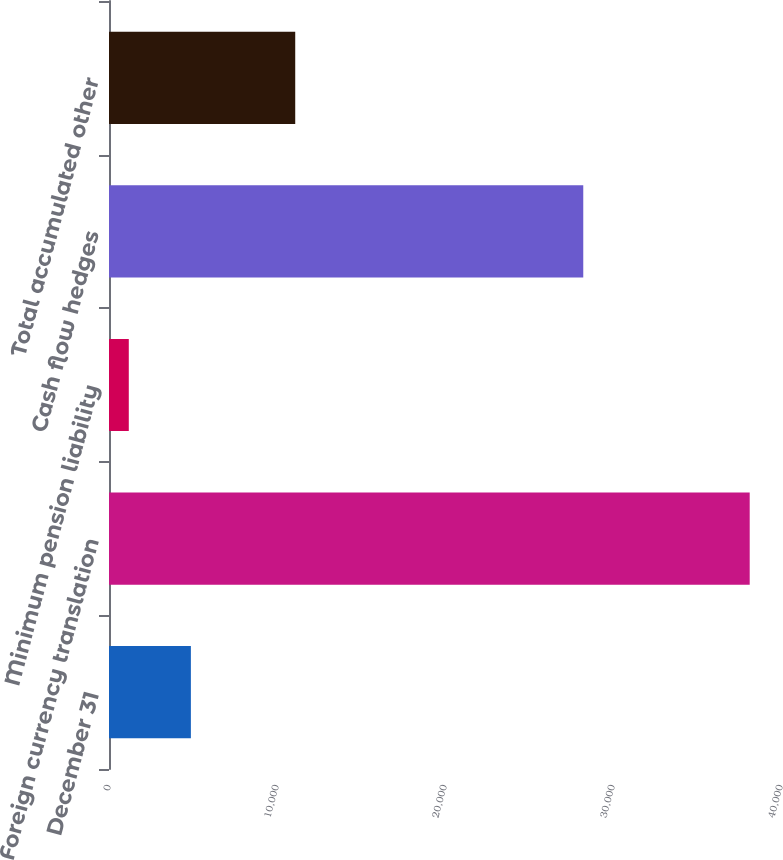Convert chart to OTSL. <chart><loc_0><loc_0><loc_500><loc_500><bar_chart><fcel>December 31<fcel>Foreign currency translation<fcel>Minimum pension liability<fcel>Cash flow hedges<fcel>Total accumulated other<nl><fcel>4873.9<fcel>38137<fcel>1178<fcel>28230<fcel>11085<nl></chart> 